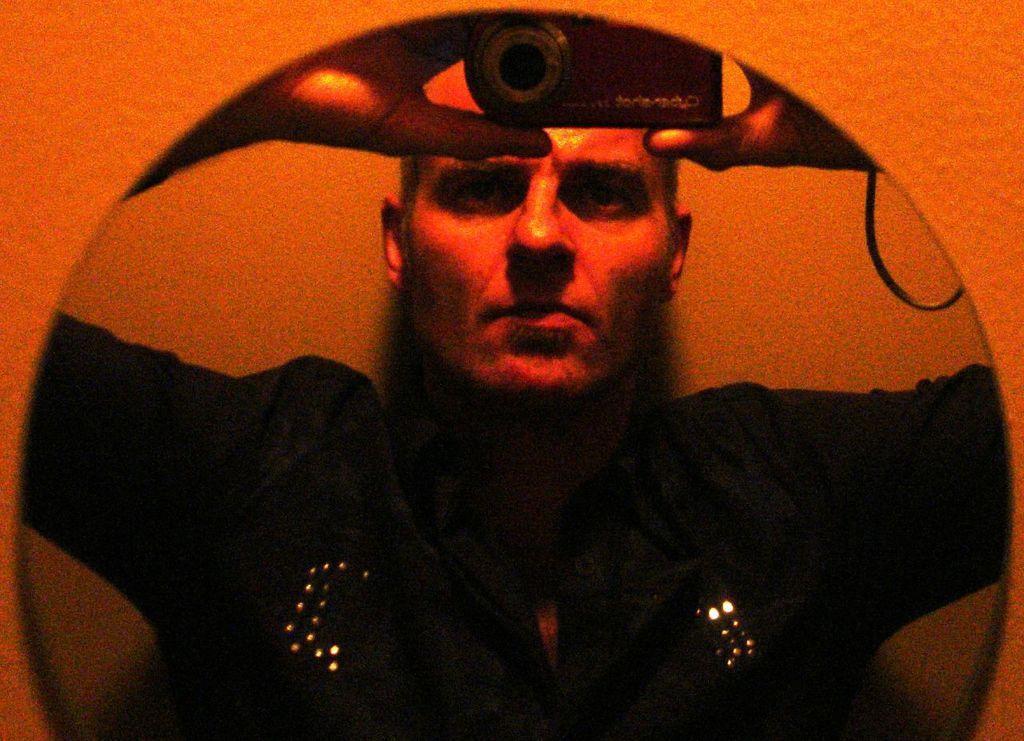Please provide a concise description of this image. In this image I can see the orange colored wall and a mirror attached to it and in the mirror I can see the reflection of a person wearing black colored dress is holding a camera. 